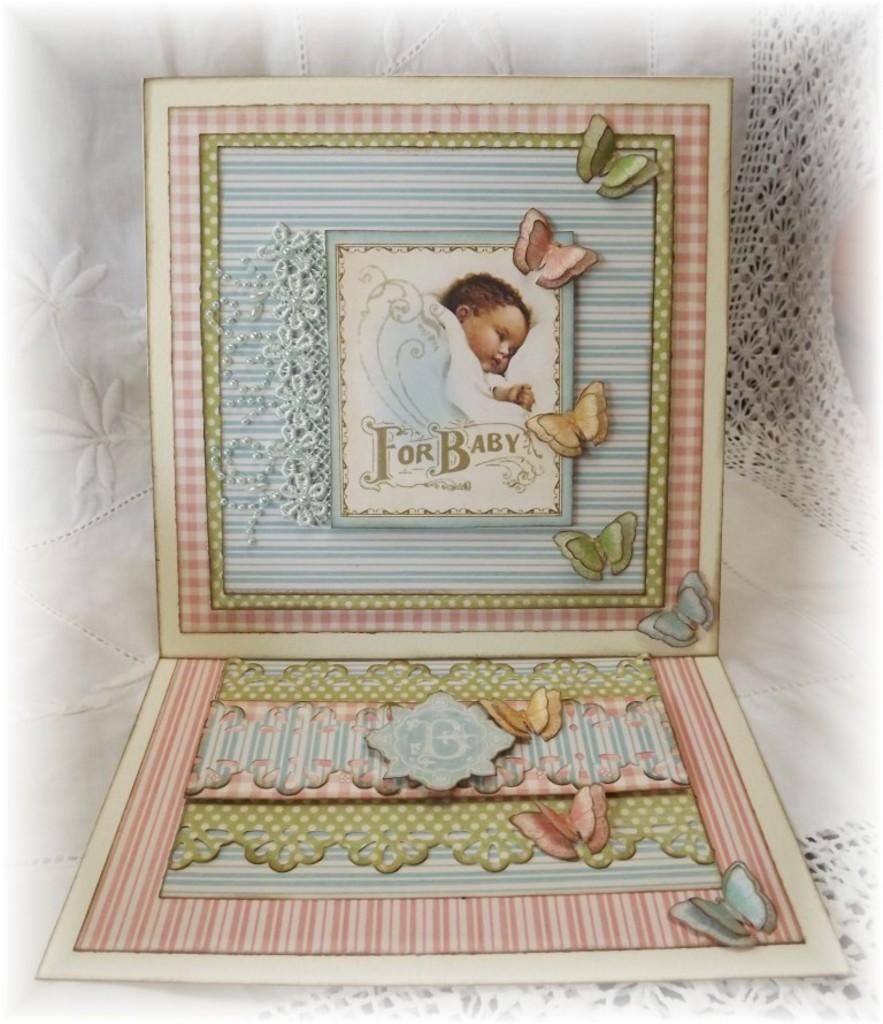<image>
Render a clear and concise summary of the photo. Card that shows a baby and says "For Baby". 